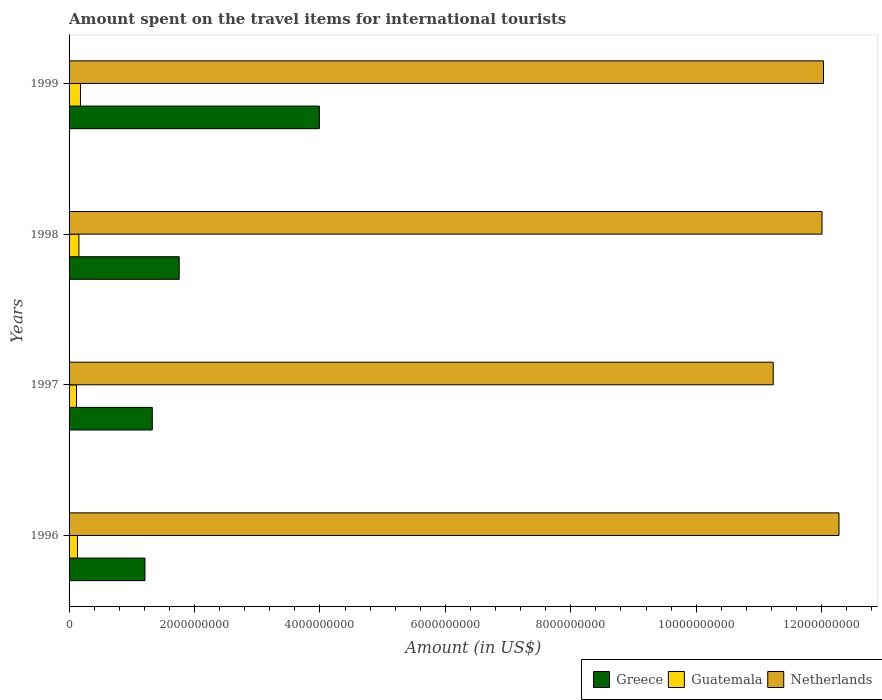Are the number of bars on each tick of the Y-axis equal?
Ensure brevity in your answer.  Yes. How many bars are there on the 2nd tick from the top?
Provide a short and direct response. 3. What is the label of the 2nd group of bars from the top?
Ensure brevity in your answer.  1998. What is the amount spent on the travel items for international tourists in Guatemala in 1996?
Offer a terse response. 1.35e+08. Across all years, what is the maximum amount spent on the travel items for international tourists in Guatemala?
Offer a terse response. 1.83e+08. Across all years, what is the minimum amount spent on the travel items for international tourists in Greece?
Provide a short and direct response. 1.21e+09. What is the total amount spent on the travel items for international tourists in Greece in the graph?
Ensure brevity in your answer.  8.28e+09. What is the difference between the amount spent on the travel items for international tourists in Netherlands in 1997 and that in 1998?
Offer a very short reply. -7.78e+08. What is the difference between the amount spent on the travel items for international tourists in Netherlands in 1996 and the amount spent on the travel items for international tourists in Guatemala in 1999?
Ensure brevity in your answer.  1.21e+1. What is the average amount spent on the travel items for international tourists in Guatemala per year?
Offer a very short reply. 1.48e+08. In the year 1999, what is the difference between the amount spent on the travel items for international tourists in Netherlands and amount spent on the travel items for international tourists in Greece?
Your answer should be compact. 8.04e+09. What is the ratio of the amount spent on the travel items for international tourists in Netherlands in 1996 to that in 1998?
Offer a terse response. 1.02. Is the amount spent on the travel items for international tourists in Guatemala in 1997 less than that in 1998?
Provide a short and direct response. Yes. What is the difference between the highest and the second highest amount spent on the travel items for international tourists in Guatemala?
Ensure brevity in your answer.  2.60e+07. What is the difference between the highest and the lowest amount spent on the travel items for international tourists in Netherlands?
Your answer should be compact. 1.05e+09. In how many years, is the amount spent on the travel items for international tourists in Netherlands greater than the average amount spent on the travel items for international tourists in Netherlands taken over all years?
Make the answer very short. 3. What does the 2nd bar from the top in 1997 represents?
Ensure brevity in your answer.  Guatemala. Is it the case that in every year, the sum of the amount spent on the travel items for international tourists in Netherlands and amount spent on the travel items for international tourists in Guatemala is greater than the amount spent on the travel items for international tourists in Greece?
Offer a terse response. Yes. How many years are there in the graph?
Provide a short and direct response. 4. Are the values on the major ticks of X-axis written in scientific E-notation?
Ensure brevity in your answer.  No. Does the graph contain any zero values?
Give a very brief answer. No. Does the graph contain grids?
Your answer should be compact. No. How many legend labels are there?
Your response must be concise. 3. How are the legend labels stacked?
Provide a succinct answer. Horizontal. What is the title of the graph?
Keep it short and to the point. Amount spent on the travel items for international tourists. Does "Syrian Arab Republic" appear as one of the legend labels in the graph?
Ensure brevity in your answer.  No. What is the label or title of the X-axis?
Your answer should be compact. Amount (in US$). What is the label or title of the Y-axis?
Make the answer very short. Years. What is the Amount (in US$) of Greece in 1996?
Provide a short and direct response. 1.21e+09. What is the Amount (in US$) of Guatemala in 1996?
Offer a terse response. 1.35e+08. What is the Amount (in US$) in Netherlands in 1996?
Your answer should be very brief. 1.23e+1. What is the Amount (in US$) in Greece in 1997?
Offer a terse response. 1.33e+09. What is the Amount (in US$) in Guatemala in 1997?
Ensure brevity in your answer.  1.19e+08. What is the Amount (in US$) in Netherlands in 1997?
Provide a short and direct response. 1.12e+1. What is the Amount (in US$) in Greece in 1998?
Your answer should be compact. 1.76e+09. What is the Amount (in US$) in Guatemala in 1998?
Offer a terse response. 1.57e+08. What is the Amount (in US$) of Netherlands in 1998?
Your response must be concise. 1.20e+1. What is the Amount (in US$) of Greece in 1999?
Offer a very short reply. 3.99e+09. What is the Amount (in US$) of Guatemala in 1999?
Ensure brevity in your answer.  1.83e+08. What is the Amount (in US$) of Netherlands in 1999?
Give a very brief answer. 1.20e+1. Across all years, what is the maximum Amount (in US$) in Greece?
Your answer should be very brief. 3.99e+09. Across all years, what is the maximum Amount (in US$) in Guatemala?
Offer a terse response. 1.83e+08. Across all years, what is the maximum Amount (in US$) of Netherlands?
Ensure brevity in your answer.  1.23e+1. Across all years, what is the minimum Amount (in US$) of Greece?
Ensure brevity in your answer.  1.21e+09. Across all years, what is the minimum Amount (in US$) in Guatemala?
Give a very brief answer. 1.19e+08. Across all years, what is the minimum Amount (in US$) of Netherlands?
Ensure brevity in your answer.  1.12e+1. What is the total Amount (in US$) of Greece in the graph?
Give a very brief answer. 8.28e+09. What is the total Amount (in US$) of Guatemala in the graph?
Provide a succinct answer. 5.94e+08. What is the total Amount (in US$) in Netherlands in the graph?
Your answer should be very brief. 4.75e+1. What is the difference between the Amount (in US$) of Greece in 1996 and that in 1997?
Keep it short and to the point. -1.17e+08. What is the difference between the Amount (in US$) in Guatemala in 1996 and that in 1997?
Provide a succinct answer. 1.60e+07. What is the difference between the Amount (in US$) in Netherlands in 1996 and that in 1997?
Make the answer very short. 1.05e+09. What is the difference between the Amount (in US$) in Greece in 1996 and that in 1998?
Ensure brevity in your answer.  -5.46e+08. What is the difference between the Amount (in US$) of Guatemala in 1996 and that in 1998?
Give a very brief answer. -2.20e+07. What is the difference between the Amount (in US$) in Netherlands in 1996 and that in 1998?
Offer a terse response. 2.71e+08. What is the difference between the Amount (in US$) in Greece in 1996 and that in 1999?
Your response must be concise. -2.78e+09. What is the difference between the Amount (in US$) in Guatemala in 1996 and that in 1999?
Offer a very short reply. -4.80e+07. What is the difference between the Amount (in US$) of Netherlands in 1996 and that in 1999?
Your answer should be compact. 2.47e+08. What is the difference between the Amount (in US$) of Greece in 1997 and that in 1998?
Keep it short and to the point. -4.29e+08. What is the difference between the Amount (in US$) of Guatemala in 1997 and that in 1998?
Offer a very short reply. -3.80e+07. What is the difference between the Amount (in US$) in Netherlands in 1997 and that in 1998?
Provide a short and direct response. -7.78e+08. What is the difference between the Amount (in US$) of Greece in 1997 and that in 1999?
Provide a short and direct response. -2.66e+09. What is the difference between the Amount (in US$) of Guatemala in 1997 and that in 1999?
Give a very brief answer. -6.40e+07. What is the difference between the Amount (in US$) of Netherlands in 1997 and that in 1999?
Ensure brevity in your answer.  -8.02e+08. What is the difference between the Amount (in US$) in Greece in 1998 and that in 1999?
Ensure brevity in your answer.  -2.24e+09. What is the difference between the Amount (in US$) of Guatemala in 1998 and that in 1999?
Your response must be concise. -2.60e+07. What is the difference between the Amount (in US$) in Netherlands in 1998 and that in 1999?
Give a very brief answer. -2.40e+07. What is the difference between the Amount (in US$) in Greece in 1996 and the Amount (in US$) in Guatemala in 1997?
Your answer should be compact. 1.09e+09. What is the difference between the Amount (in US$) of Greece in 1996 and the Amount (in US$) of Netherlands in 1997?
Provide a short and direct response. -1.00e+1. What is the difference between the Amount (in US$) of Guatemala in 1996 and the Amount (in US$) of Netherlands in 1997?
Provide a succinct answer. -1.11e+1. What is the difference between the Amount (in US$) of Greece in 1996 and the Amount (in US$) of Guatemala in 1998?
Provide a succinct answer. 1.05e+09. What is the difference between the Amount (in US$) in Greece in 1996 and the Amount (in US$) in Netherlands in 1998?
Give a very brief answer. -1.08e+1. What is the difference between the Amount (in US$) in Guatemala in 1996 and the Amount (in US$) in Netherlands in 1998?
Keep it short and to the point. -1.19e+1. What is the difference between the Amount (in US$) in Greece in 1996 and the Amount (in US$) in Guatemala in 1999?
Provide a succinct answer. 1.03e+09. What is the difference between the Amount (in US$) in Greece in 1996 and the Amount (in US$) in Netherlands in 1999?
Give a very brief answer. -1.08e+1. What is the difference between the Amount (in US$) of Guatemala in 1996 and the Amount (in US$) of Netherlands in 1999?
Your answer should be very brief. -1.19e+1. What is the difference between the Amount (in US$) in Greece in 1997 and the Amount (in US$) in Guatemala in 1998?
Offer a very short reply. 1.17e+09. What is the difference between the Amount (in US$) in Greece in 1997 and the Amount (in US$) in Netherlands in 1998?
Give a very brief answer. -1.07e+1. What is the difference between the Amount (in US$) of Guatemala in 1997 and the Amount (in US$) of Netherlands in 1998?
Offer a very short reply. -1.19e+1. What is the difference between the Amount (in US$) in Greece in 1997 and the Amount (in US$) in Guatemala in 1999?
Provide a succinct answer. 1.14e+09. What is the difference between the Amount (in US$) of Greece in 1997 and the Amount (in US$) of Netherlands in 1999?
Ensure brevity in your answer.  -1.07e+1. What is the difference between the Amount (in US$) of Guatemala in 1997 and the Amount (in US$) of Netherlands in 1999?
Ensure brevity in your answer.  -1.19e+1. What is the difference between the Amount (in US$) of Greece in 1998 and the Amount (in US$) of Guatemala in 1999?
Provide a short and direct response. 1.57e+09. What is the difference between the Amount (in US$) of Greece in 1998 and the Amount (in US$) of Netherlands in 1999?
Your answer should be compact. -1.03e+1. What is the difference between the Amount (in US$) of Guatemala in 1998 and the Amount (in US$) of Netherlands in 1999?
Keep it short and to the point. -1.19e+1. What is the average Amount (in US$) of Greece per year?
Ensure brevity in your answer.  2.07e+09. What is the average Amount (in US$) of Guatemala per year?
Provide a succinct answer. 1.48e+08. What is the average Amount (in US$) of Netherlands per year?
Provide a succinct answer. 1.19e+1. In the year 1996, what is the difference between the Amount (in US$) of Greece and Amount (in US$) of Guatemala?
Ensure brevity in your answer.  1.08e+09. In the year 1996, what is the difference between the Amount (in US$) in Greece and Amount (in US$) in Netherlands?
Offer a terse response. -1.11e+1. In the year 1996, what is the difference between the Amount (in US$) of Guatemala and Amount (in US$) of Netherlands?
Offer a terse response. -1.21e+1. In the year 1997, what is the difference between the Amount (in US$) of Greece and Amount (in US$) of Guatemala?
Your answer should be compact. 1.21e+09. In the year 1997, what is the difference between the Amount (in US$) of Greece and Amount (in US$) of Netherlands?
Your answer should be compact. -9.90e+09. In the year 1997, what is the difference between the Amount (in US$) of Guatemala and Amount (in US$) of Netherlands?
Provide a succinct answer. -1.11e+1. In the year 1998, what is the difference between the Amount (in US$) in Greece and Amount (in US$) in Guatemala?
Offer a terse response. 1.60e+09. In the year 1998, what is the difference between the Amount (in US$) of Greece and Amount (in US$) of Netherlands?
Keep it short and to the point. -1.02e+1. In the year 1998, what is the difference between the Amount (in US$) in Guatemala and Amount (in US$) in Netherlands?
Make the answer very short. -1.18e+1. In the year 1999, what is the difference between the Amount (in US$) of Greece and Amount (in US$) of Guatemala?
Your answer should be very brief. 3.81e+09. In the year 1999, what is the difference between the Amount (in US$) of Greece and Amount (in US$) of Netherlands?
Provide a short and direct response. -8.04e+09. In the year 1999, what is the difference between the Amount (in US$) of Guatemala and Amount (in US$) of Netherlands?
Offer a terse response. -1.18e+1. What is the ratio of the Amount (in US$) of Greece in 1996 to that in 1997?
Your response must be concise. 0.91. What is the ratio of the Amount (in US$) in Guatemala in 1996 to that in 1997?
Ensure brevity in your answer.  1.13. What is the ratio of the Amount (in US$) in Netherlands in 1996 to that in 1997?
Ensure brevity in your answer.  1.09. What is the ratio of the Amount (in US$) of Greece in 1996 to that in 1998?
Your answer should be very brief. 0.69. What is the ratio of the Amount (in US$) of Guatemala in 1996 to that in 1998?
Offer a terse response. 0.86. What is the ratio of the Amount (in US$) in Netherlands in 1996 to that in 1998?
Ensure brevity in your answer.  1.02. What is the ratio of the Amount (in US$) of Greece in 1996 to that in 1999?
Your answer should be very brief. 0.3. What is the ratio of the Amount (in US$) of Guatemala in 1996 to that in 1999?
Keep it short and to the point. 0.74. What is the ratio of the Amount (in US$) in Netherlands in 1996 to that in 1999?
Offer a terse response. 1.02. What is the ratio of the Amount (in US$) of Greece in 1997 to that in 1998?
Your response must be concise. 0.76. What is the ratio of the Amount (in US$) in Guatemala in 1997 to that in 1998?
Offer a terse response. 0.76. What is the ratio of the Amount (in US$) in Netherlands in 1997 to that in 1998?
Offer a very short reply. 0.94. What is the ratio of the Amount (in US$) in Greece in 1997 to that in 1999?
Offer a terse response. 0.33. What is the ratio of the Amount (in US$) in Guatemala in 1997 to that in 1999?
Ensure brevity in your answer.  0.65. What is the ratio of the Amount (in US$) in Greece in 1998 to that in 1999?
Offer a terse response. 0.44. What is the ratio of the Amount (in US$) in Guatemala in 1998 to that in 1999?
Ensure brevity in your answer.  0.86. What is the ratio of the Amount (in US$) of Netherlands in 1998 to that in 1999?
Give a very brief answer. 1. What is the difference between the highest and the second highest Amount (in US$) of Greece?
Your response must be concise. 2.24e+09. What is the difference between the highest and the second highest Amount (in US$) in Guatemala?
Provide a short and direct response. 2.60e+07. What is the difference between the highest and the second highest Amount (in US$) of Netherlands?
Provide a succinct answer. 2.47e+08. What is the difference between the highest and the lowest Amount (in US$) in Greece?
Keep it short and to the point. 2.78e+09. What is the difference between the highest and the lowest Amount (in US$) in Guatemala?
Provide a short and direct response. 6.40e+07. What is the difference between the highest and the lowest Amount (in US$) in Netherlands?
Your answer should be compact. 1.05e+09. 